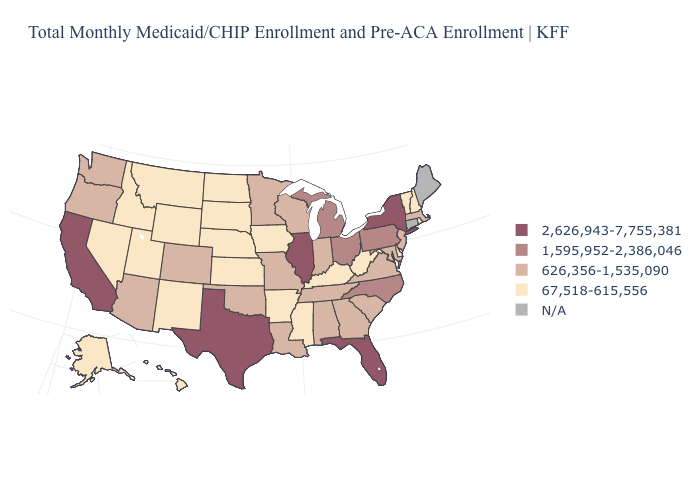Which states have the highest value in the USA?
Write a very short answer. California, Florida, Illinois, New York, Texas. What is the lowest value in the USA?
Short answer required. 67,518-615,556. What is the value of Vermont?
Write a very short answer. 67,518-615,556. Name the states that have a value in the range 1,595,952-2,386,046?
Give a very brief answer. Michigan, North Carolina, Ohio, Pennsylvania. Does Texas have the highest value in the USA?
Short answer required. Yes. What is the value of Rhode Island?
Concise answer only. 67,518-615,556. What is the value of Pennsylvania?
Quick response, please. 1,595,952-2,386,046. Which states hav the highest value in the MidWest?
Keep it brief. Illinois. Among the states that border Nebraska , does Colorado have the lowest value?
Short answer required. No. What is the value of Wyoming?
Be succinct. 67,518-615,556. Which states have the highest value in the USA?
Concise answer only. California, Florida, Illinois, New York, Texas. Which states have the lowest value in the South?
Short answer required. Arkansas, Delaware, Kentucky, Mississippi, West Virginia. What is the lowest value in the South?
Give a very brief answer. 67,518-615,556. Is the legend a continuous bar?
Give a very brief answer. No. 